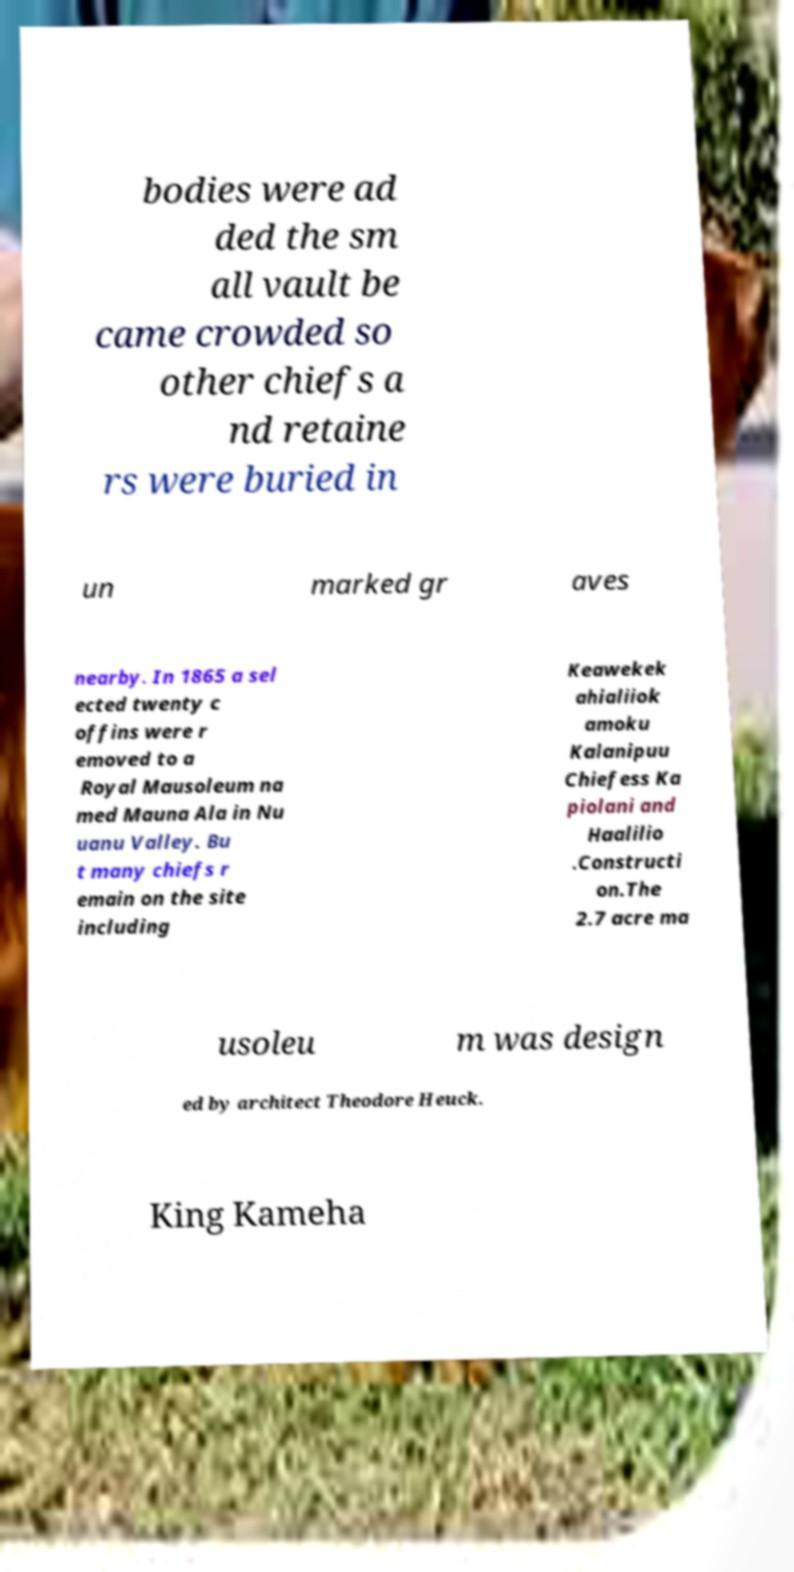For documentation purposes, I need the text within this image transcribed. Could you provide that? bodies were ad ded the sm all vault be came crowded so other chiefs a nd retaine rs were buried in un marked gr aves nearby. In 1865 a sel ected twenty c offins were r emoved to a Royal Mausoleum na med Mauna Ala in Nu uanu Valley. Bu t many chiefs r emain on the site including Keawekek ahialiiok amoku Kalanipuu Chiefess Ka piolani and Haalilio .Constructi on.The 2.7 acre ma usoleu m was design ed by architect Theodore Heuck. King Kameha 